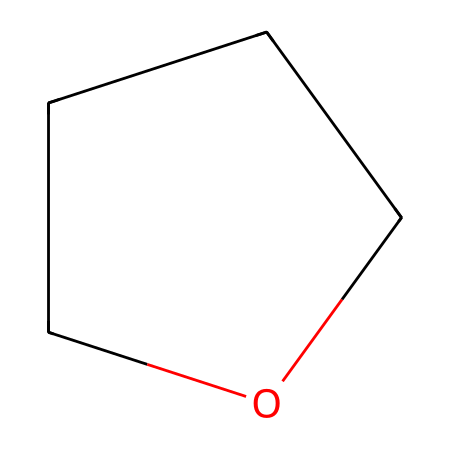How many carbon atoms are in tetrahydrofuran? The SMILES representation "C1CCCO1" indicates that there are four 'C' characters, which represent carbon atoms.
Answer: four What is the functional group present in tetrahydrofuran? The structure contains an ether linkage due to the presence of oxygen connected to two alkyl groups (carbon chains).
Answer: ether How many hydrogen atoms are associated with tetrahydrofuran? Each carbon in tetrahydrofuran will typically bond with enough hydrogens to make four bonds total. Given there are four carbon atoms, the hydrogens calculated from the structure is eight.
Answer: eight What is the total number of atoms in the molecule? The molecule contains four carbon atoms, one oxygen atom, and eight hydrogen atoms, making a total of thirteen atoms.
Answer: thirteen Is tetrahydrofuran a cyclic compound? The ‘C1’ and ‘O1’ in the SMILES notation indicate that the molecule is cyclic, forming a ring structure.
Answer: yes Does tetrahydrofuran have polar or non-polar characteristics? The presence of the oxygen atom in the ring introduces a polar character to the molecule, affecting its solubility in water and interaction with other polar substances.
Answer: polar 